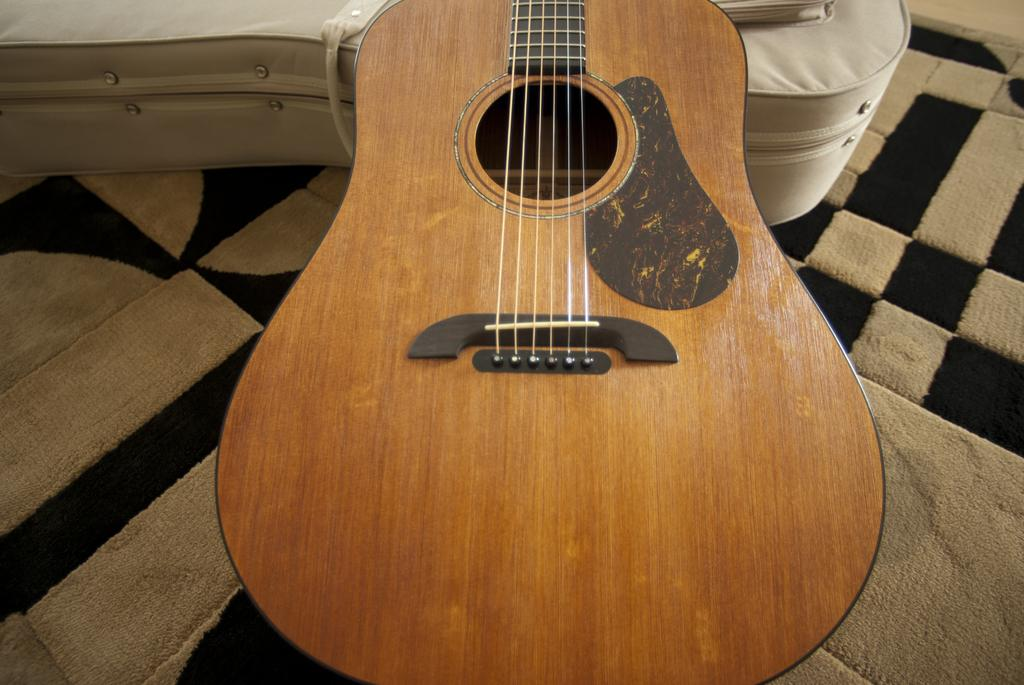What type of furniture is present in the image? There is a bed in the image. What musical instrument can be seen in the image? There is a guitar in the image. What part of the guitar is missing in the image? There is no indication that any part of the guitar is missing in the image. Who is the owner of the guitar in the image? The image does not provide information about the owner of the guitar. 